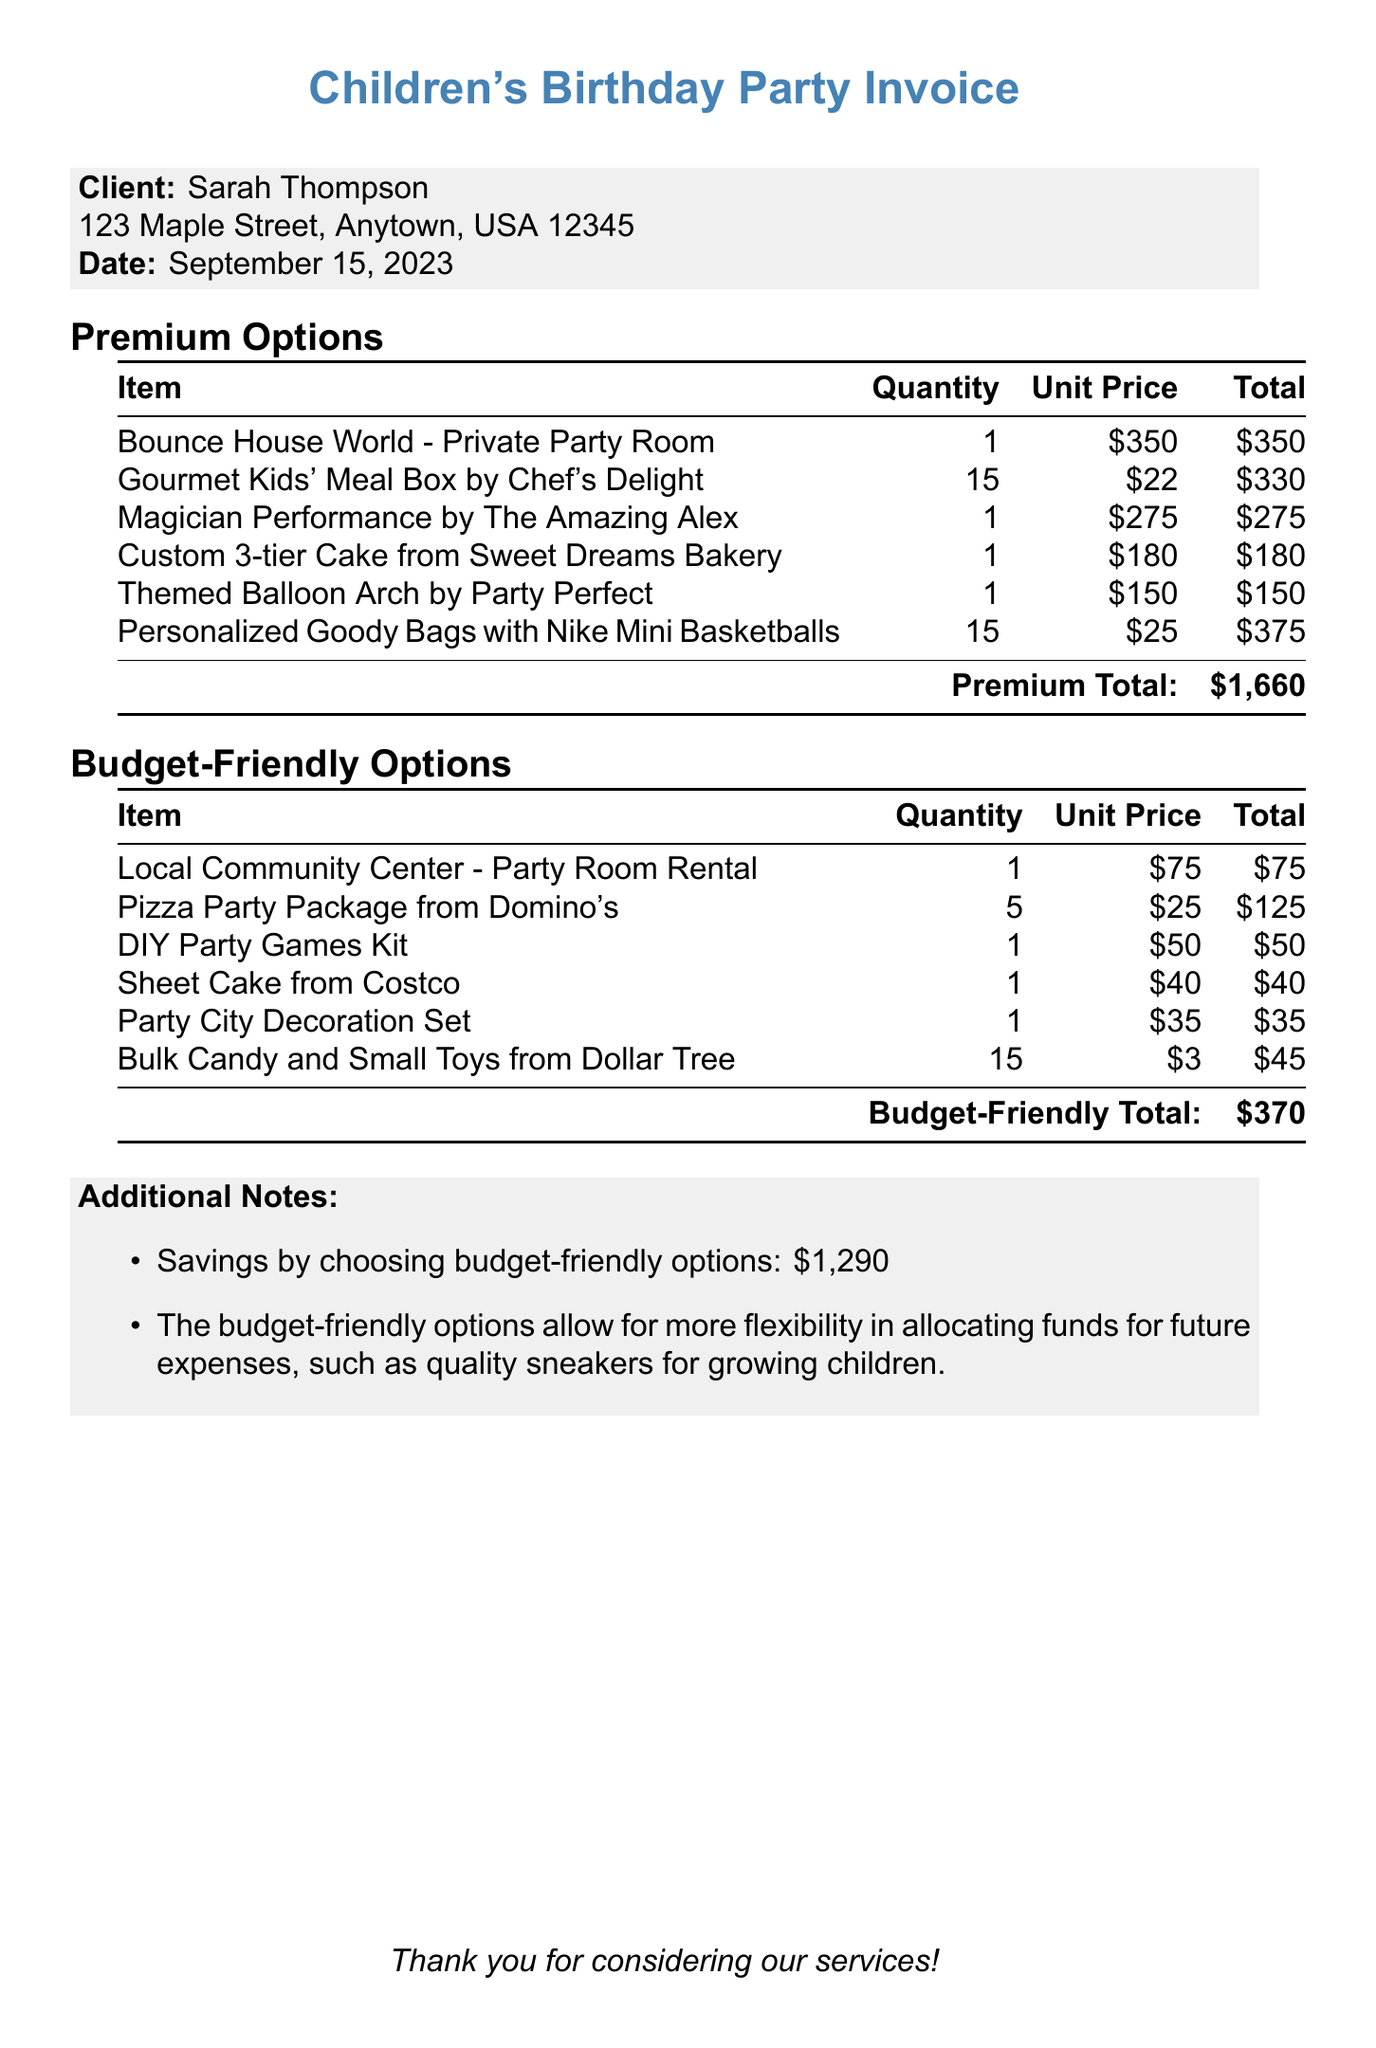What is the client's name? The client's name is listed at the top of the document under the client details.
Answer: Sarah Thompson What is the total cost of the premium options? The premium options total is indicated at the bottom of the premium options section.
Answer: $1,660 What item is associated with the budget-friendly option for catering? The item in the budget-friendly category for catering is found in the budget-friendly options table.
Answer: Pizza Party Package from Domino's How much can be saved by choosing budget-friendly options? The savings are detailed in the additional notes section of the document.
Answer: $1,290 What is the unit price of the custom cake in the premium options? The unit price for the custom cake is provided in the premium options table.
Answer: $180 Which entertainment option is more expensive: the magician or the DIY games? A comparison of the entertainment options shows their respective costs in the document.
Answer: The magician What type of document is this? The document is identified by the header and title.
Answer: Invoice 